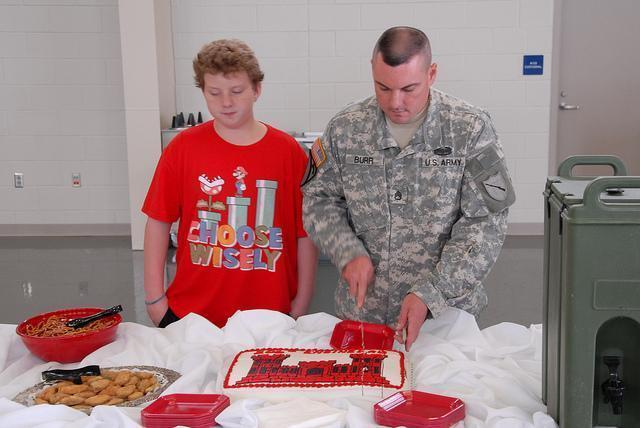How many bowls are in the picture?
Give a very brief answer. 2. How many people are in the picture?
Give a very brief answer. 2. How many red cars are there?
Give a very brief answer. 0. 